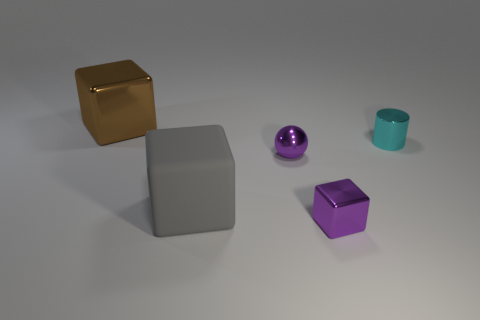Does the large gray rubber object have the same shape as the large brown thing?
Your answer should be very brief. Yes. The gray cube has what size?
Give a very brief answer. Large. Is the number of tiny purple shiny cubes in front of the small ball greater than the number of purple things behind the small cylinder?
Keep it short and to the point. Yes. Are there any cyan cylinders in front of the brown shiny thing?
Your answer should be compact. Yes. Are there any other shiny things of the same size as the cyan object?
Offer a very short reply. Yes. What is the color of the small cylinder that is the same material as the small purple block?
Offer a terse response. Cyan. What is the tiny purple ball made of?
Your answer should be compact. Metal. The gray matte object has what shape?
Provide a succinct answer. Cube. How many large rubber blocks have the same color as the large shiny cube?
Provide a short and direct response. 0. There is a large object that is in front of the tiny purple metal ball right of the large thing right of the big metal cube; what is it made of?
Keep it short and to the point. Rubber. 